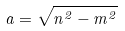Convert formula to latex. <formula><loc_0><loc_0><loc_500><loc_500>a = \sqrt { n ^ { 2 } - m ^ { 2 } }</formula> 